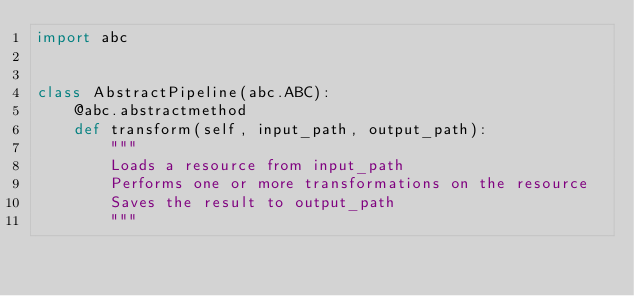<code> <loc_0><loc_0><loc_500><loc_500><_Python_>import abc


class AbstractPipeline(abc.ABC):
    @abc.abstractmethod
    def transform(self, input_path, output_path):
        """
        Loads a resource from input_path
        Performs one or more transformations on the resource
        Saves the result to output_path
        """
</code> 